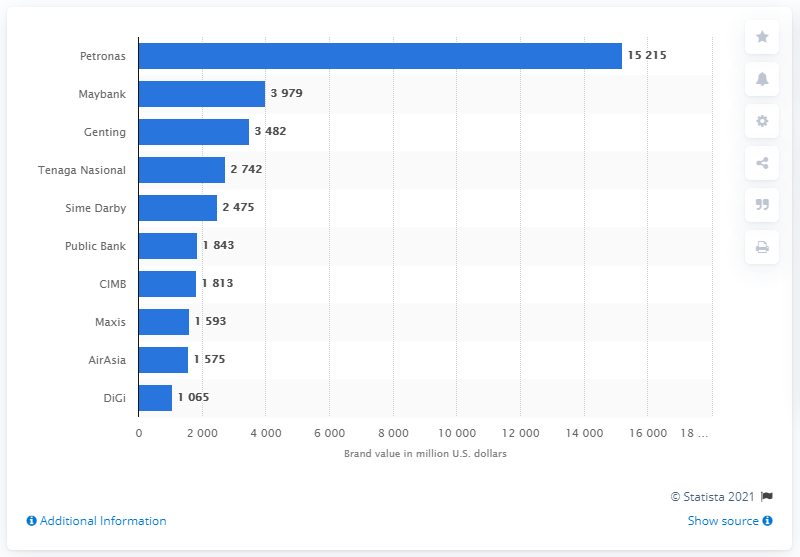How do the values of the largest brands compare to each other? According to the bar chart in the image, the largest brand, Petronas, has a significantly higher brand value compared to the others, listed at around 15.215 billion U.S. dollars. The second most valuable brand is Maybank, but it is less than a quarter of Petronas's value at nearly 3.979 billion U.S. dollars. The other brands show a much more gradual decline in value from there. 